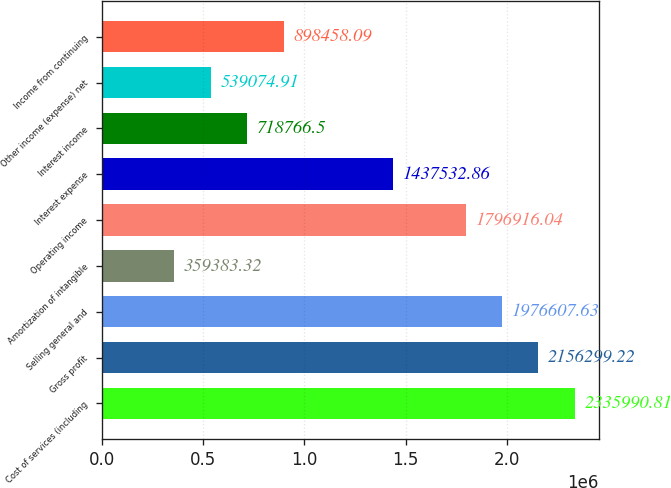Convert chart. <chart><loc_0><loc_0><loc_500><loc_500><bar_chart><fcel>Cost of services (including<fcel>Gross profit<fcel>Selling general and<fcel>Amortization of intangible<fcel>Operating income<fcel>Interest expense<fcel>Interest income<fcel>Other income (expense) net<fcel>Income from continuing<nl><fcel>2.33599e+06<fcel>2.1563e+06<fcel>1.97661e+06<fcel>359383<fcel>1.79692e+06<fcel>1.43753e+06<fcel>718766<fcel>539075<fcel>898458<nl></chart> 